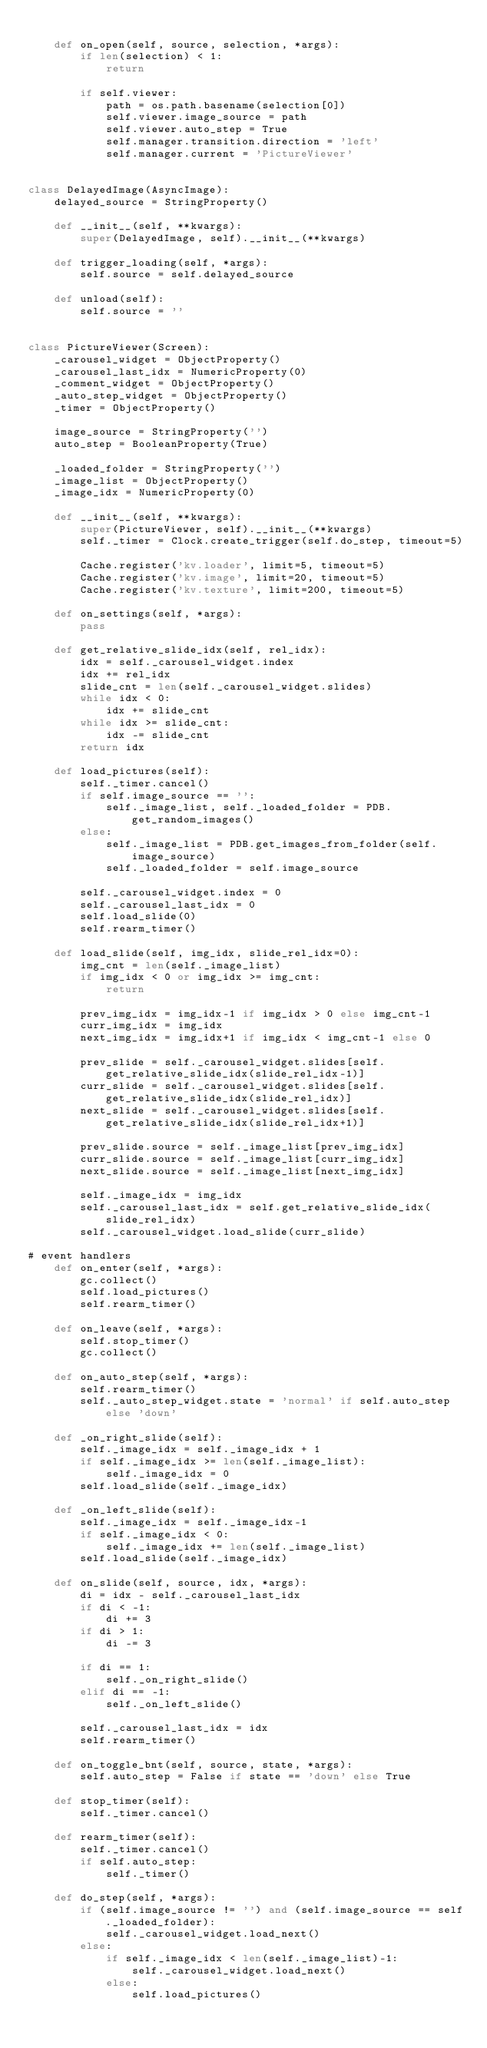<code> <loc_0><loc_0><loc_500><loc_500><_Python_>
    def on_open(self, source, selection, *args):
        if len(selection) < 1:
            return

        if self.viewer:
            path = os.path.basename(selection[0])
            self.viewer.image_source = path
            self.viewer.auto_step = True
            self.manager.transition.direction = 'left'
            self.manager.current = 'PictureViewer'


class DelayedImage(AsyncImage):
    delayed_source = StringProperty()

    def __init__(self, **kwargs):
        super(DelayedImage, self).__init__(**kwargs)

    def trigger_loading(self, *args):
        self.source = self.delayed_source

    def unload(self):
        self.source = ''


class PictureViewer(Screen):
    _carousel_widget = ObjectProperty()
    _carousel_last_idx = NumericProperty(0)
    _comment_widget = ObjectProperty()
    _auto_step_widget = ObjectProperty()
    _timer = ObjectProperty()

    image_source = StringProperty('')
    auto_step = BooleanProperty(True)

    _loaded_folder = StringProperty('')
    _image_list = ObjectProperty()
    _image_idx = NumericProperty(0)

    def __init__(self, **kwargs):
        super(PictureViewer, self).__init__(**kwargs)
        self._timer = Clock.create_trigger(self.do_step, timeout=5)

        Cache.register('kv.loader', limit=5, timeout=5)
        Cache.register('kv.image', limit=20, timeout=5)
        Cache.register('kv.texture', limit=200, timeout=5)

    def on_settings(self, *args):
        pass

    def get_relative_slide_idx(self, rel_idx):
        idx = self._carousel_widget.index
        idx += rel_idx
        slide_cnt = len(self._carousel_widget.slides)
        while idx < 0:
            idx += slide_cnt
        while idx >= slide_cnt:
            idx -= slide_cnt
        return idx

    def load_pictures(self):
        self._timer.cancel()
        if self.image_source == '':
            self._image_list, self._loaded_folder = PDB.get_random_images()
        else:
            self._image_list = PDB.get_images_from_folder(self.image_source)
            self._loaded_folder = self.image_source

        self._carousel_widget.index = 0
        self._carousel_last_idx = 0
        self.load_slide(0)
        self.rearm_timer()

    def load_slide(self, img_idx, slide_rel_idx=0):
        img_cnt = len(self._image_list)
        if img_idx < 0 or img_idx >= img_cnt:
            return

        prev_img_idx = img_idx-1 if img_idx > 0 else img_cnt-1
        curr_img_idx = img_idx
        next_img_idx = img_idx+1 if img_idx < img_cnt-1 else 0

        prev_slide = self._carousel_widget.slides[self.get_relative_slide_idx(slide_rel_idx-1)]
        curr_slide = self._carousel_widget.slides[self.get_relative_slide_idx(slide_rel_idx)]
        next_slide = self._carousel_widget.slides[self.get_relative_slide_idx(slide_rel_idx+1)]

        prev_slide.source = self._image_list[prev_img_idx]
        curr_slide.source = self._image_list[curr_img_idx]
        next_slide.source = self._image_list[next_img_idx]

        self._image_idx = img_idx
        self._carousel_last_idx = self.get_relative_slide_idx(slide_rel_idx)
        self._carousel_widget.load_slide(curr_slide)

# event handlers
    def on_enter(self, *args):
        gc.collect()
        self.load_pictures()
        self.rearm_timer()

    def on_leave(self, *args):
        self.stop_timer()
        gc.collect()

    def on_auto_step(self, *args):
        self.rearm_timer()
        self._auto_step_widget.state = 'normal' if self.auto_step else 'down'

    def _on_right_slide(self):
        self._image_idx = self._image_idx + 1
        if self._image_idx >= len(self._image_list):
            self._image_idx = 0
        self.load_slide(self._image_idx)

    def _on_left_slide(self):
        self._image_idx = self._image_idx-1
        if self._image_idx < 0:
            self._image_idx += len(self._image_list)
        self.load_slide(self._image_idx)

    def on_slide(self, source, idx, *args):
        di = idx - self._carousel_last_idx
        if di < -1:
            di += 3
        if di > 1:
            di -= 3

        if di == 1:
            self._on_right_slide()
        elif di == -1:
            self._on_left_slide()

        self._carousel_last_idx = idx
        self.rearm_timer()

    def on_toggle_bnt(self, source, state, *args):
        self.auto_step = False if state == 'down' else True

    def stop_timer(self):
        self._timer.cancel()

    def rearm_timer(self):
        self._timer.cancel()
        if self.auto_step:
            self._timer()

    def do_step(self, *args):
        if (self.image_source != '') and (self.image_source == self._loaded_folder):
            self._carousel_widget.load_next()
        else:
            if self._image_idx < len(self._image_list)-1:
                self._carousel_widget.load_next()
            else:
                self.load_pictures()



</code> 